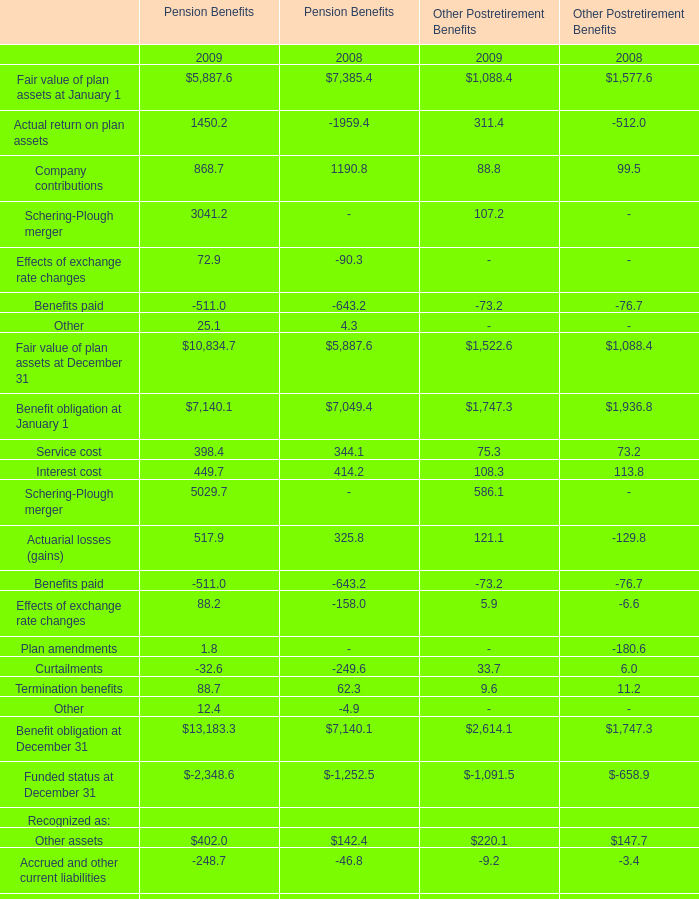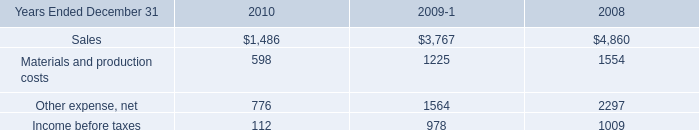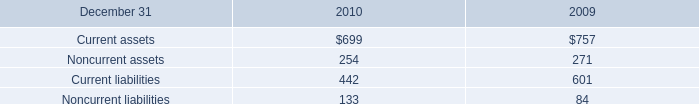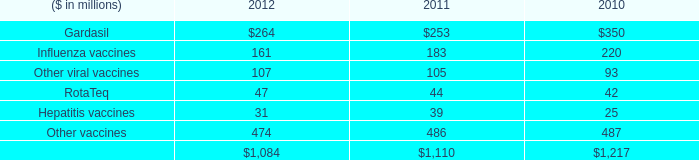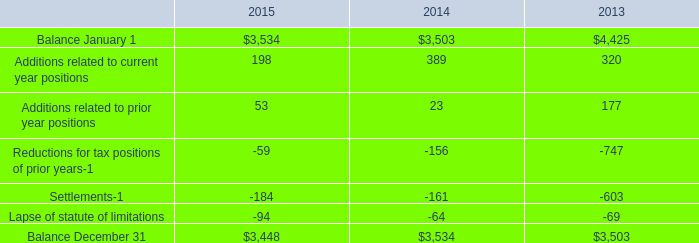What is the sum of Additions related to current year positions in 2015 and Influenza vaccines in 2012 ? (in million) 
Computations: (198 + 161)
Answer: 359.0. 